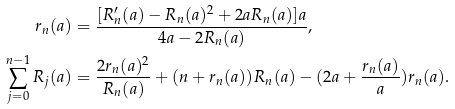Convert formula to latex. <formula><loc_0><loc_0><loc_500><loc_500>r _ { n } ( a ) & = \frac { [ R ^ { \prime } _ { n } ( a ) - R _ { n } ( a ) ^ { 2 } + 2 a R _ { n } ( a ) ] a } { 4 a - 2 R _ { n } ( a ) } , \\ \sum _ { j = 0 } ^ { n - 1 } R _ { j } ( a ) & = \frac { 2 r _ { n } ( a ) ^ { 2 } } { R _ { n } ( a ) } + ( n + r _ { n } ( a ) ) R _ { n } ( a ) - ( 2 a + \frac { r _ { n } ( a ) } { a } ) r _ { n } ( a ) .</formula> 